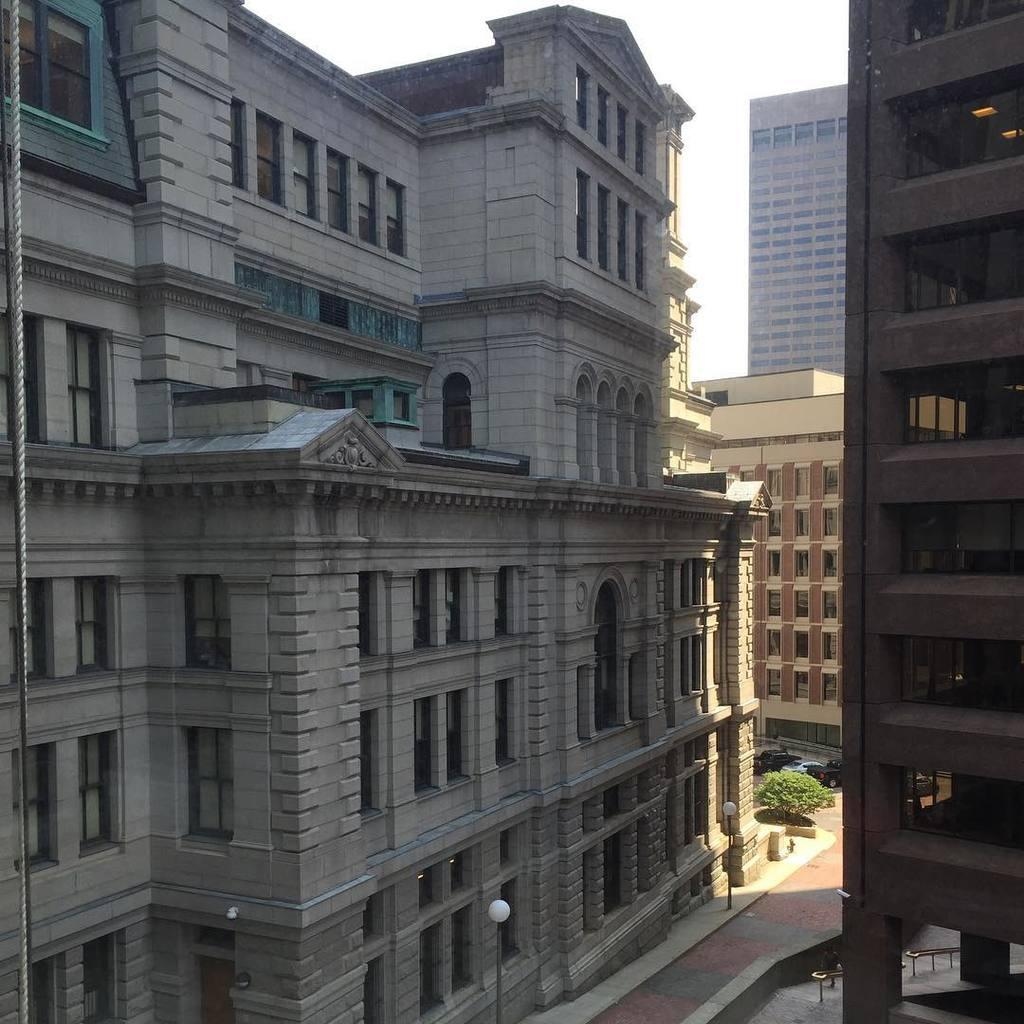What type of structures are visible in the image? There are buildings in the image. What can be seen on the ground in the image? There is a walkway in the image. What are the poles with lights used for? The poles with lights are likely used for illumination. How many cars can be seen on the right side of the image? There are two cars on the right side of the image. What type of windows do the buildings have? The buildings have glass windows. What is the condition of the sky in the image? The sky is clear in the image. Where is the sink located in the image? There is no sink present in the image. What type of thrill can be experienced by the cars in the image? The cars in the image are stationary, so there is no thrill experienced. Is there a bomb visible in the image? There is no bomb present in the image. 